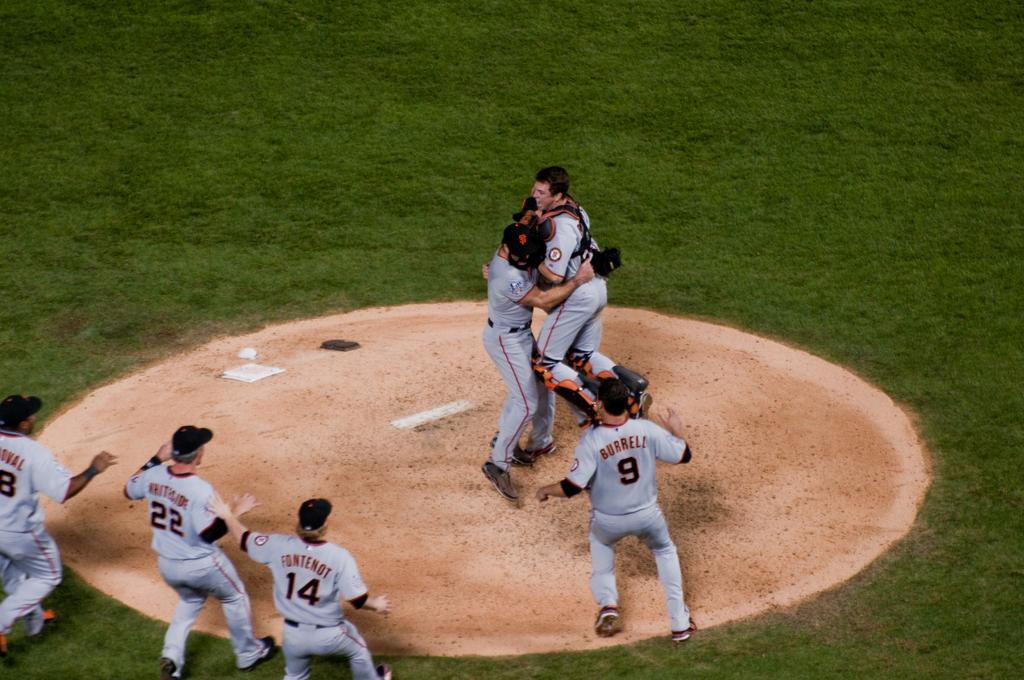<image>
Create a compact narrative representing the image presented. Burrell is about to join the pitcher and catcher in the celebration. 